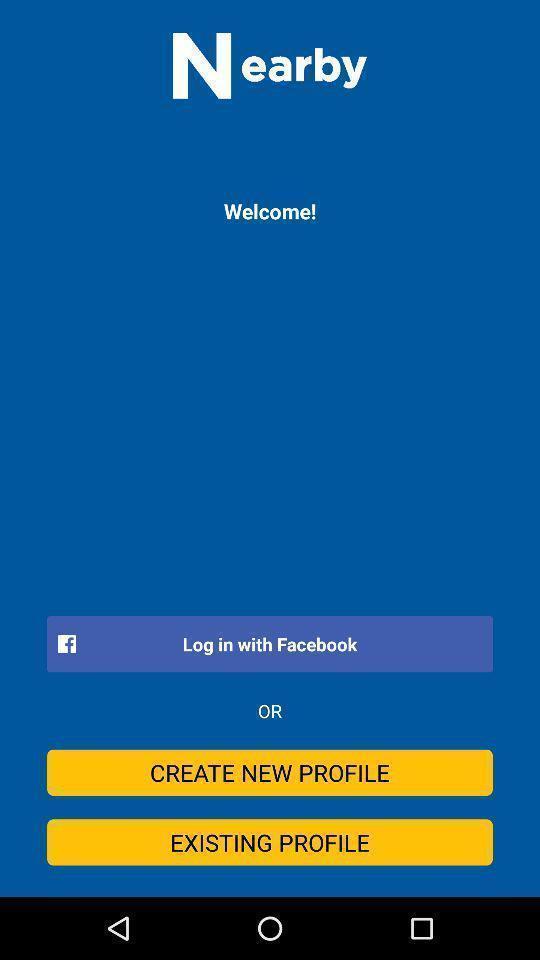Tell me what you see in this picture. Welcome page for a social application. 